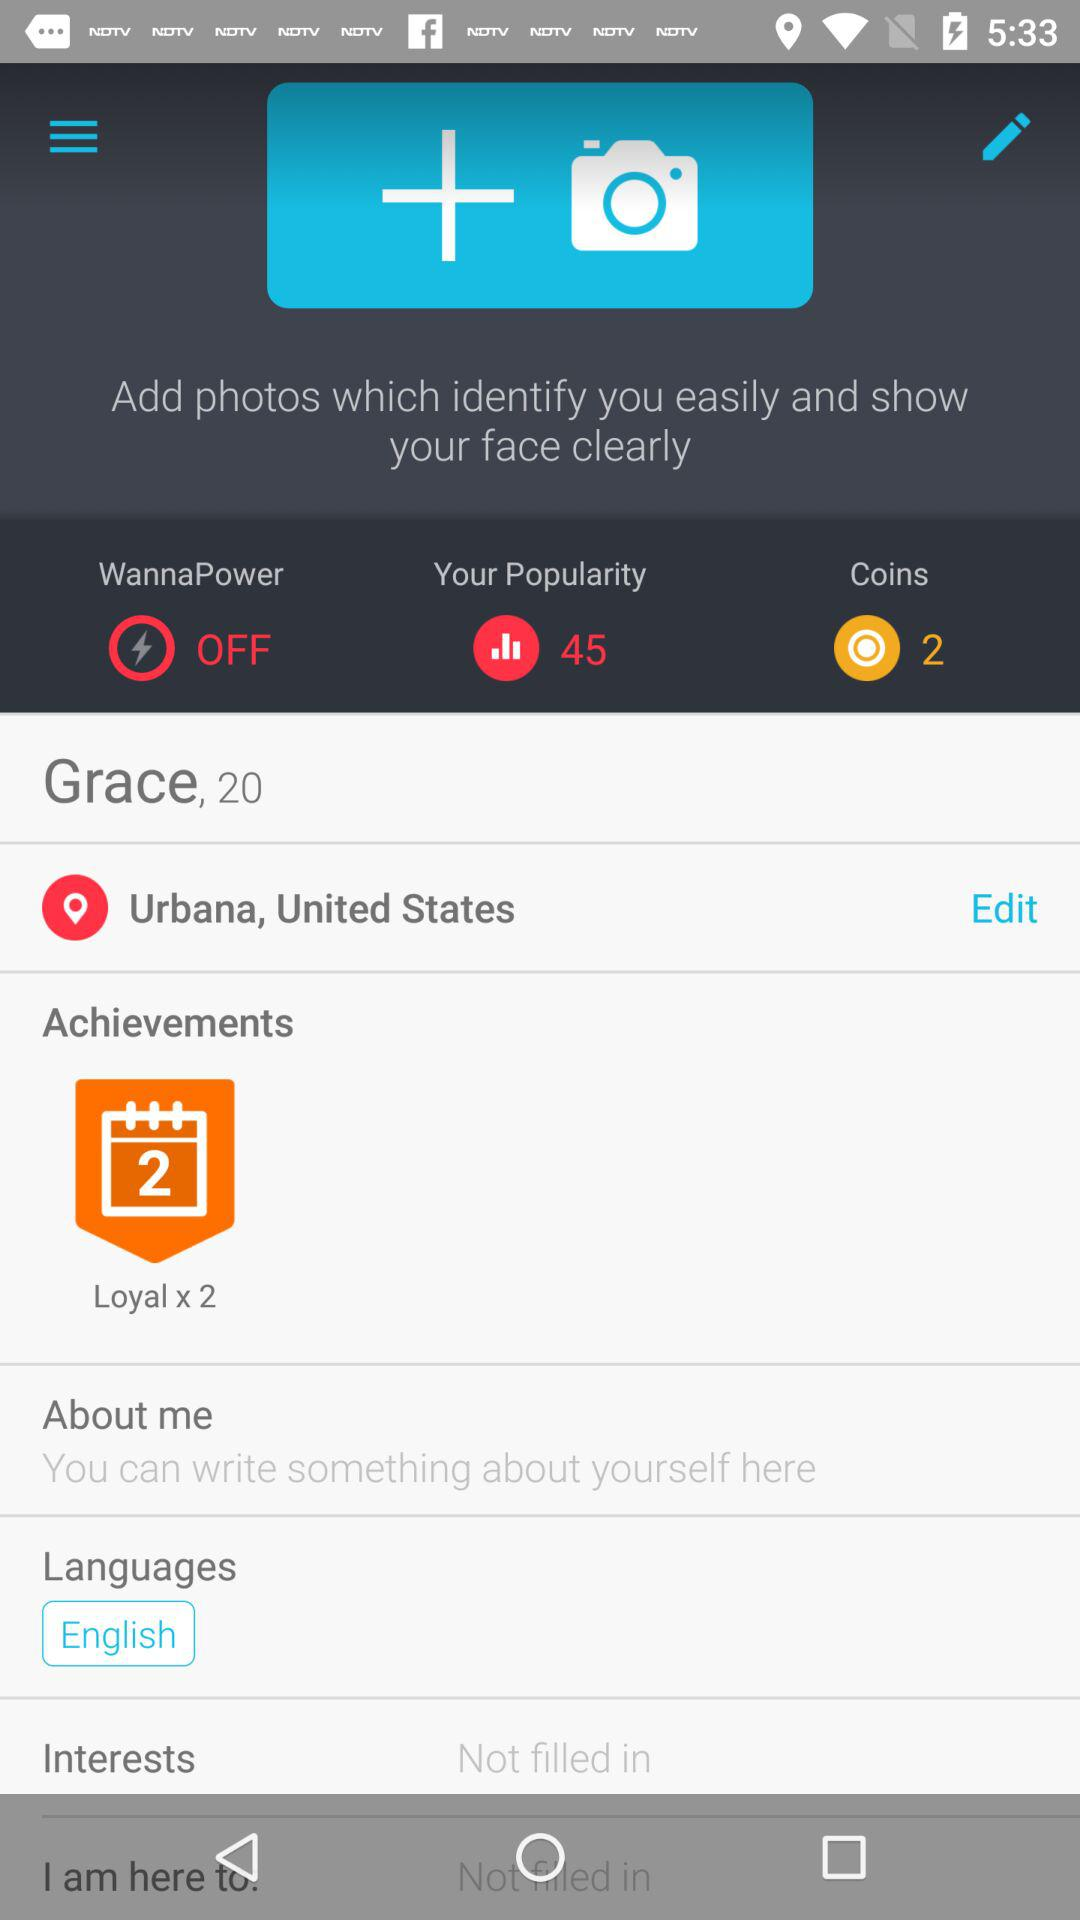How many more languages does Grace speak than interests?
Answer the question using a single word or phrase. 1 